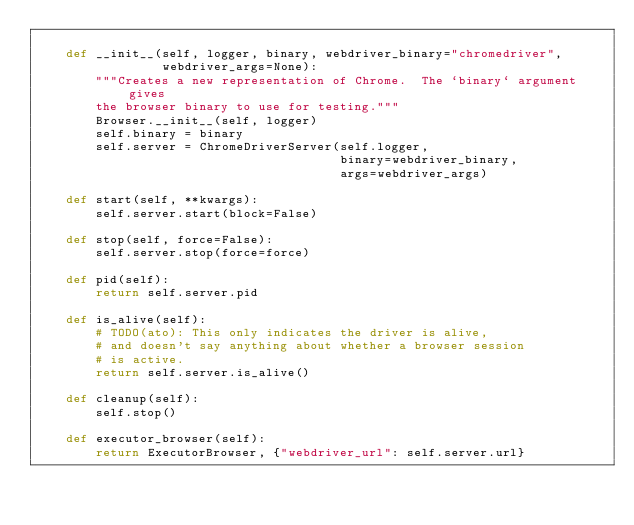<code> <loc_0><loc_0><loc_500><loc_500><_Python_>
    def __init__(self, logger, binary, webdriver_binary="chromedriver",
                 webdriver_args=None):
        """Creates a new representation of Chrome.  The `binary` argument gives
        the browser binary to use for testing."""
        Browser.__init__(self, logger)
        self.binary = binary
        self.server = ChromeDriverServer(self.logger,
                                         binary=webdriver_binary,
                                         args=webdriver_args)

    def start(self, **kwargs):
        self.server.start(block=False)

    def stop(self, force=False):
        self.server.stop(force=force)

    def pid(self):
        return self.server.pid

    def is_alive(self):
        # TODO(ato): This only indicates the driver is alive,
        # and doesn't say anything about whether a browser session
        # is active.
        return self.server.is_alive()

    def cleanup(self):
        self.stop()

    def executor_browser(self):
        return ExecutorBrowser, {"webdriver_url": self.server.url}
</code> 